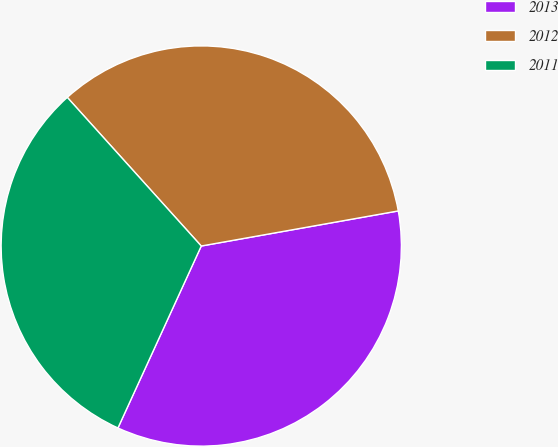Convert chart to OTSL. <chart><loc_0><loc_0><loc_500><loc_500><pie_chart><fcel>2013<fcel>2012<fcel>2011<nl><fcel>34.64%<fcel>33.87%<fcel>31.49%<nl></chart> 